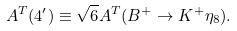<formula> <loc_0><loc_0><loc_500><loc_500>A ^ { T } ( 4 ^ { \prime } ) \equiv \sqrt { 6 } A ^ { T } ( B ^ { + } \to K ^ { + } \eta _ { 8 } ) .</formula> 